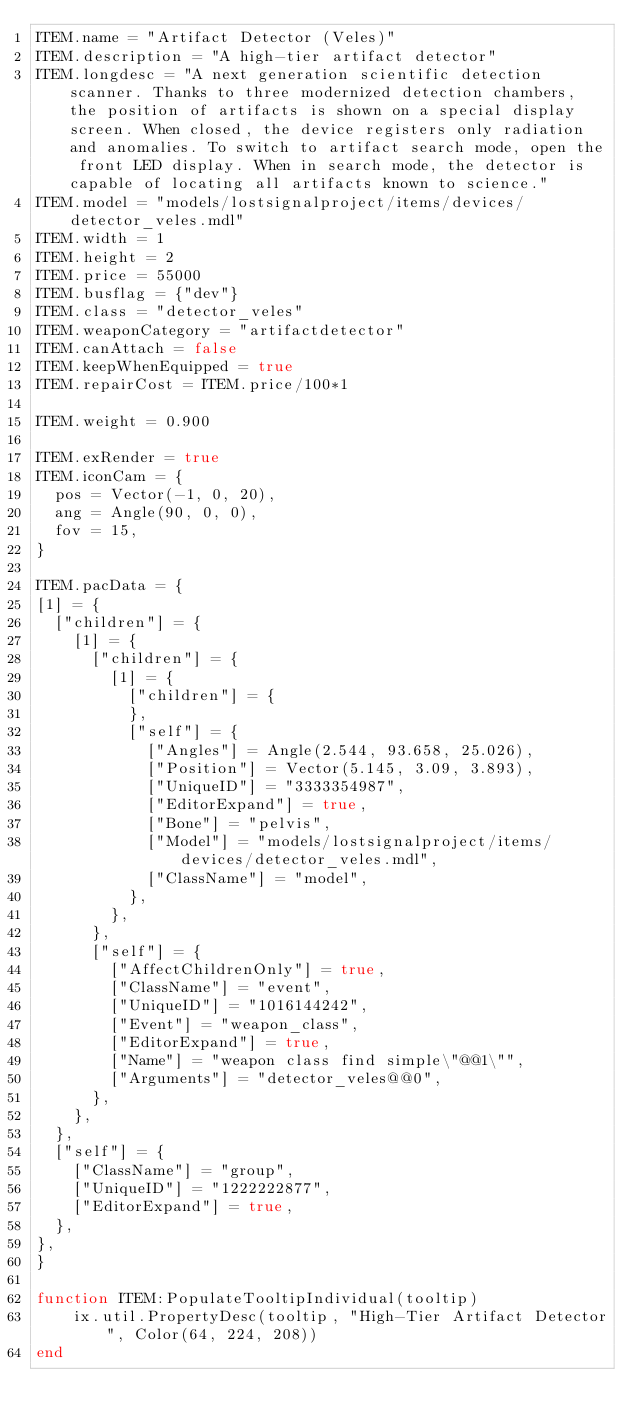Convert code to text. <code><loc_0><loc_0><loc_500><loc_500><_Lua_>ITEM.name = "Artifact Detector (Veles)"
ITEM.description = "A high-tier artifact detector"
ITEM.longdesc = "A next generation scientific detection scanner. Thanks to three modernized detection chambers, the position of artifacts is shown on a special display screen. When closed, the device registers only radiation and anomalies. To switch to artifact search mode, open the front LED display. When in search mode, the detector is capable of locating all artifacts known to science."
ITEM.model = "models/lostsignalproject/items/devices/detector_veles.mdl"
ITEM.width = 1
ITEM.height = 2
ITEM.price = 55000
ITEM.busflag = {"dev"}
ITEM.class = "detector_veles"
ITEM.weaponCategory = "artifactdetector"
ITEM.canAttach = false
ITEM.keepWhenEquipped = true
ITEM.repairCost = ITEM.price/100*1

ITEM.weight = 0.900

ITEM.exRender = true
ITEM.iconCam = {
	pos = Vector(-1, 0, 20),
	ang = Angle(90, 0, 0),
	fov = 15,
}

ITEM.pacData = {
[1] = {
	["children"] = {
		[1] = {
			["children"] = {
				[1] = {
					["children"] = {
					},
					["self"] = {
						["Angles"] = Angle(2.544, 93.658, 25.026),
						["Position"] = Vector(5.145, 3.09, 3.893),
						["UniqueID"] = "3333354987",
						["EditorExpand"] = true,
						["Bone"] = "pelvis",
						["Model"] = "models/lostsignalproject/items/devices/detector_veles.mdl",
						["ClassName"] = "model",
					},
				},
			},
			["self"] = {
				["AffectChildrenOnly"] = true,
				["ClassName"] = "event",
				["UniqueID"] = "1016144242",
				["Event"] = "weapon_class",
				["EditorExpand"] = true,
				["Name"] = "weapon class find simple\"@@1\"",
				["Arguments"] = "detector_veles@@0",
			},
		},
	},
	["self"] = {
		["ClassName"] = "group",
		["UniqueID"] = "1222222877",
		["EditorExpand"] = true,
	},
},
}

function ITEM:PopulateTooltipIndividual(tooltip)
    ix.util.PropertyDesc(tooltip, "High-Tier Artifact Detector", Color(64, 224, 208))
end</code> 